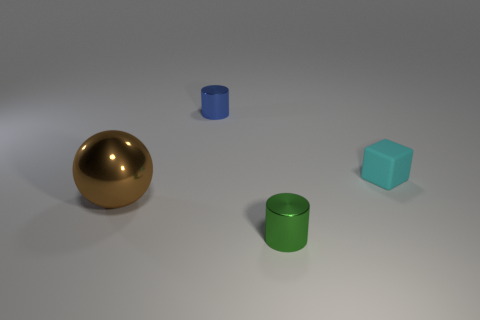What shape is the thing that is to the right of the tiny shiny cylinder in front of the shiny object behind the sphere? The object to the right of the small shiny blue cylinder, located in front of the larger shiny green cylinder and behind the golden sphere, is a cube. More specifically, it appears to be a light teal or cyan colored cube with a matte surface, distinguishing its texture from the shinier cylinders and the sphere. 